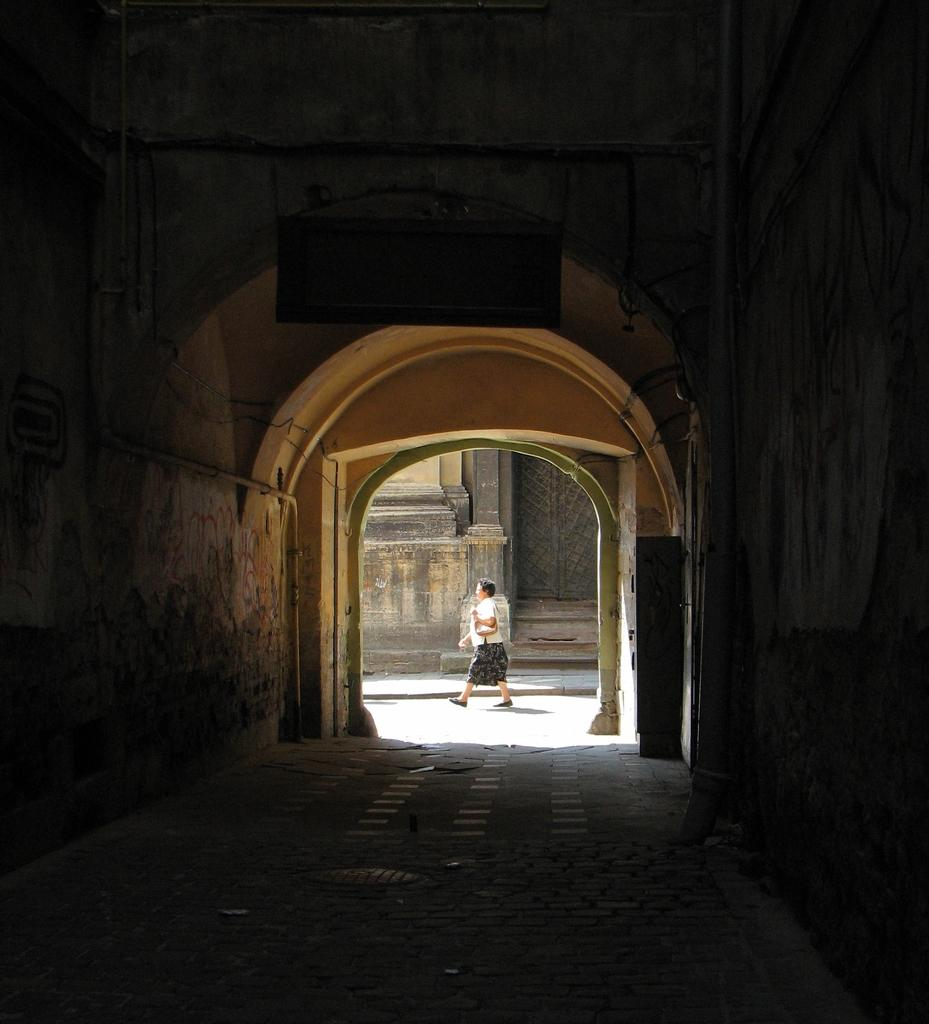What type of structure is present in the image? There is an arch in the image. What can be seen beneath the arch? There is a footpath in the image. What is the person in the image doing? A person is walking in the image. What is the person wearing? The person is wearing clothes. How many women are holding oranges in the image? There are no women or oranges present in the image. What invention is being demonstrated by the person in the image? There is no invention being demonstrated by the person in the image; they are simply walking. 